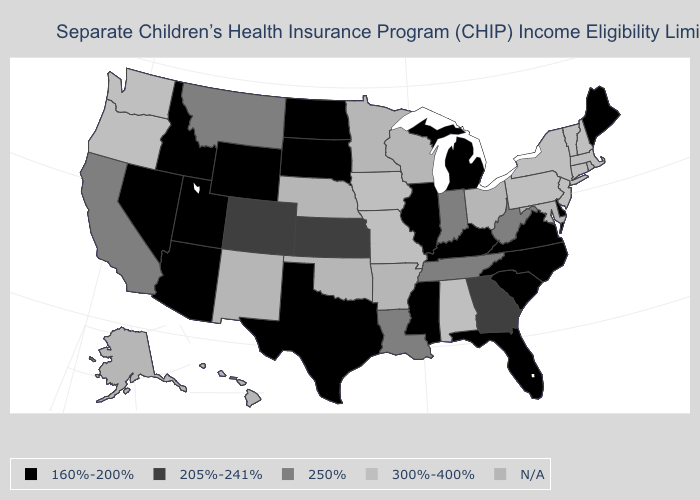What is the value of Vermont?
Keep it brief. 300%-400%. Which states have the lowest value in the USA?
Answer briefly. Arizona, Delaware, Florida, Idaho, Illinois, Kentucky, Maine, Michigan, Mississippi, Nevada, North Carolina, North Dakota, South Carolina, South Dakota, Texas, Utah, Virginia, Wyoming. Name the states that have a value in the range 205%-241%?
Quick response, please. Colorado, Georgia, Kansas. What is the value of Iowa?
Short answer required. 300%-400%. Does Texas have the lowest value in the USA?
Concise answer only. Yes. Does the first symbol in the legend represent the smallest category?
Write a very short answer. Yes. What is the lowest value in the USA?
Quick response, please. 160%-200%. Among the states that border Louisiana , which have the highest value?
Write a very short answer. Mississippi, Texas. What is the lowest value in the West?
Answer briefly. 160%-200%. How many symbols are there in the legend?
Give a very brief answer. 5. What is the value of Illinois?
Concise answer only. 160%-200%. What is the highest value in states that border Florida?
Short answer required. 300%-400%. Name the states that have a value in the range 300%-400%?
Answer briefly. Alabama, Connecticut, Iowa, Massachusetts, Missouri, New Hampshire, New Jersey, New York, Oregon, Pennsylvania, Vermont, Washington. What is the value of Iowa?
Keep it brief. 300%-400%. 